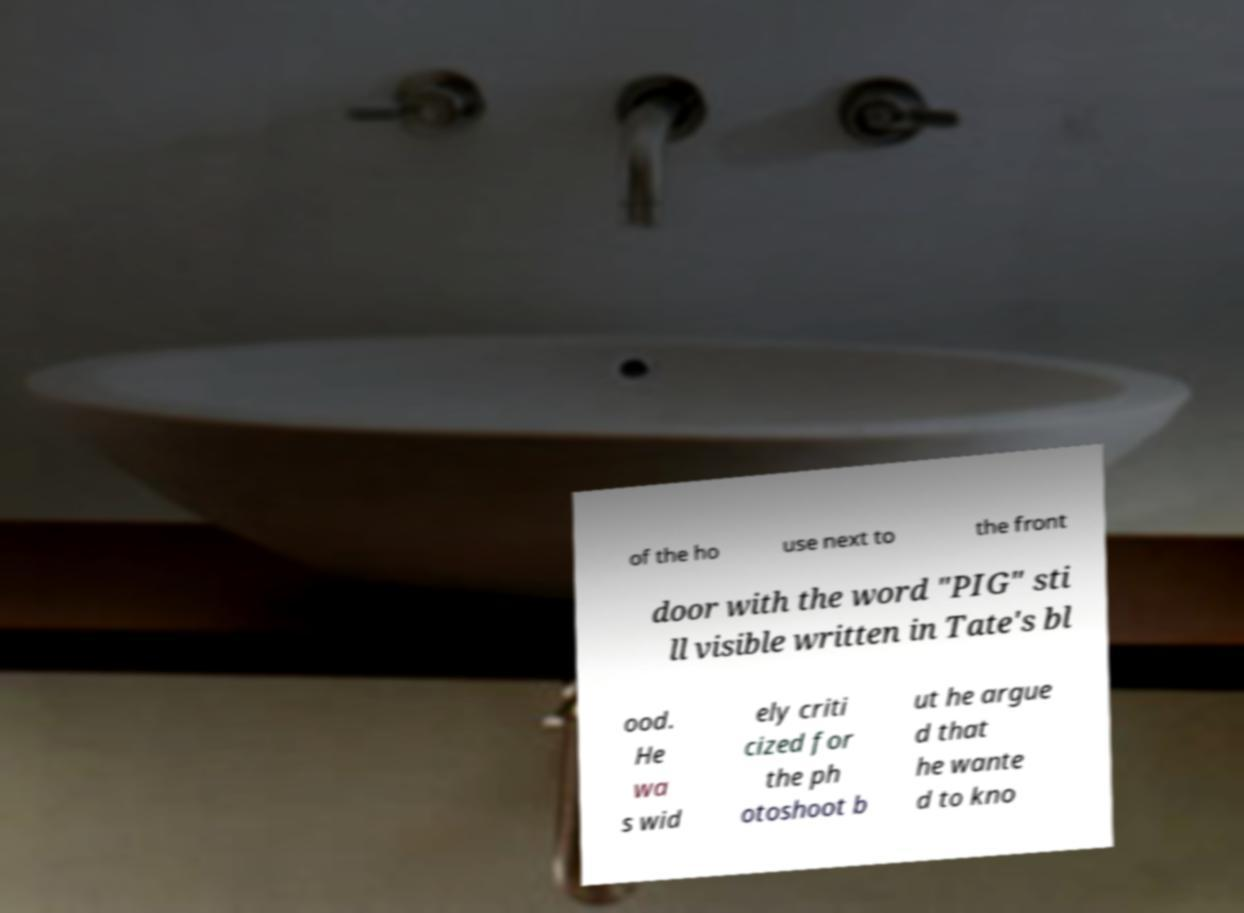I need the written content from this picture converted into text. Can you do that? of the ho use next to the front door with the word "PIG" sti ll visible written in Tate's bl ood. He wa s wid ely criti cized for the ph otoshoot b ut he argue d that he wante d to kno 